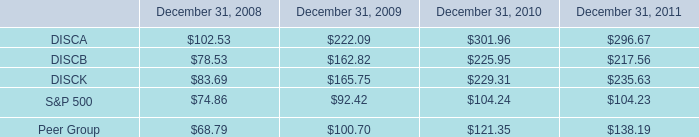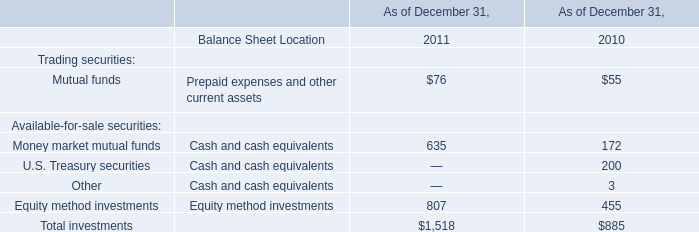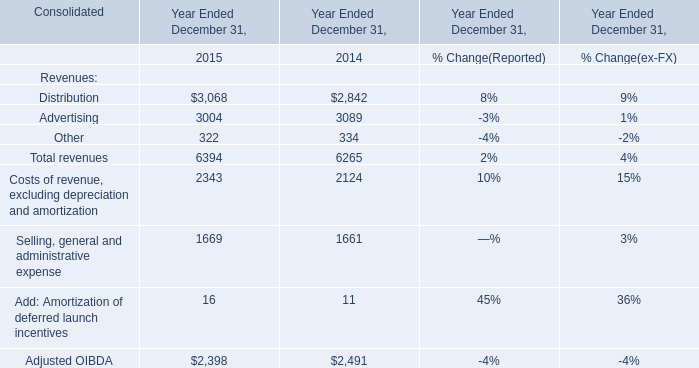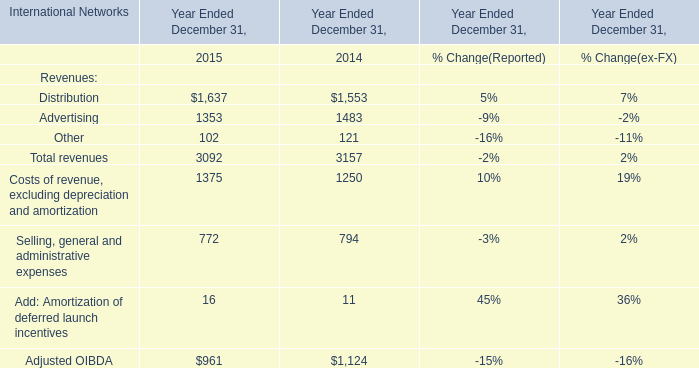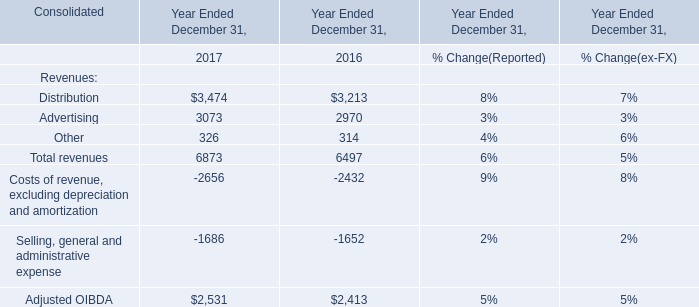what was the percentage cumulative total shareholder return on discb from september 18 , 2008 to december 31 , 2011? 
Computations: ((217.56 - 100) / 100)
Answer: 1.1756. 